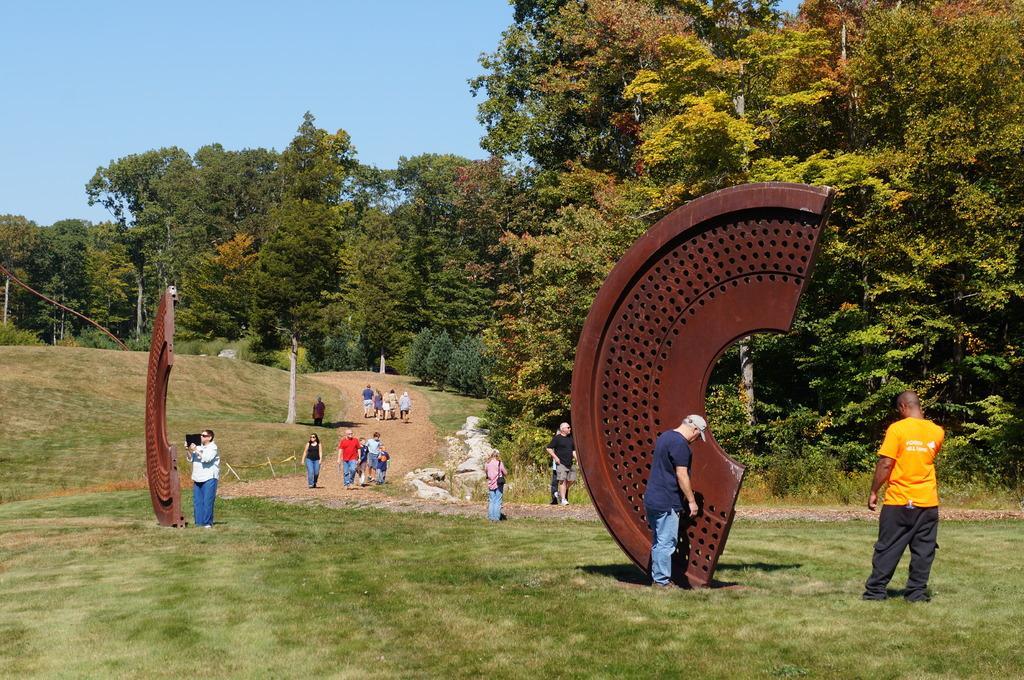Could you give a brief overview of what you see in this image? In this image we can see these people are on the grass also we can see brown color objects on the ground. Here we can see these people are walking on the road, we can see trees and the blue color sky in the background. 